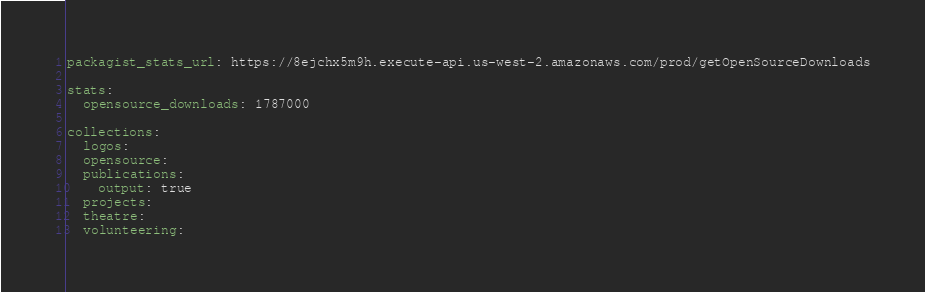<code> <loc_0><loc_0><loc_500><loc_500><_YAML_>packagist_stats_url: https://8ejchx5m9h.execute-api.us-west-2.amazonaws.com/prod/getOpenSourceDownloads

stats:
  opensource_downloads: 1787000

collections:
  logos:
  opensource:
  publications:
    output: true
  projects:
  theatre:
  volunteering:


</code> 